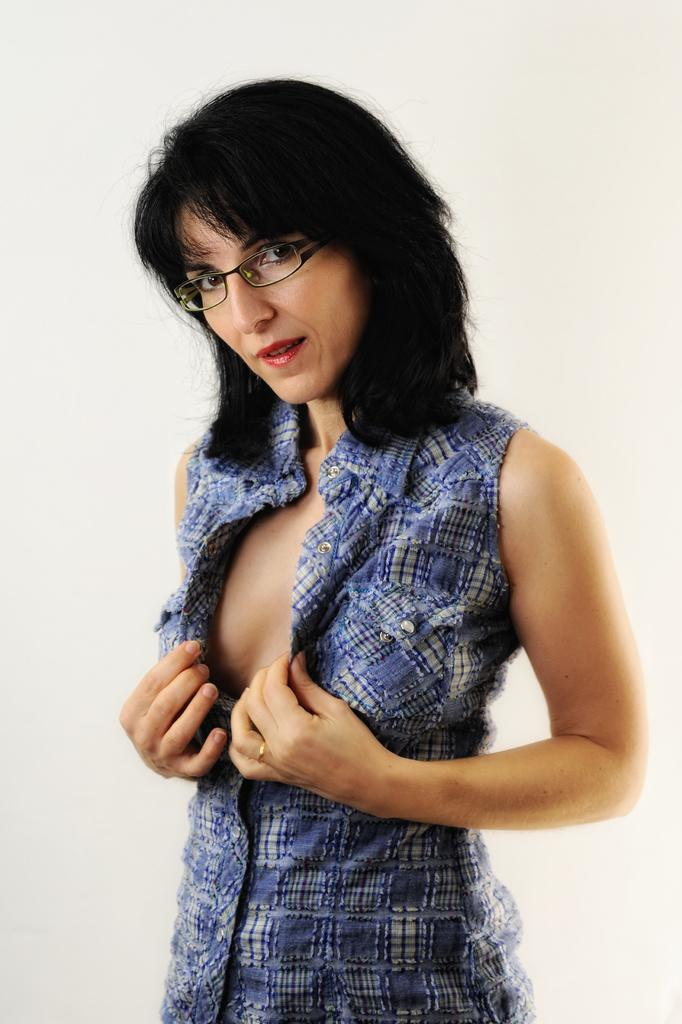What is the main subject of the image? The main subject of the image is a woman. Can you describe the woman's hair in the image? The woman has short hair. What type of clothing is the woman wearing in the image? The woman is wearing a skirt. What accessory is the woman wearing in the image? The woman is wearing spectacles. What type of cave can be seen in the background of the image? There is no cave present in the image. What type of loss is the woman experiencing in the image? There is no indication of any loss in the image; the woman is simply depicted as she is. 